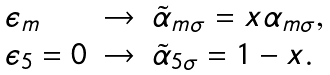Convert formula to latex. <formula><loc_0><loc_0><loc_500><loc_500>\begin{array} { l l l } \epsilon _ { m } & \rightarrow & \tilde { \alpha } _ { m \sigma } = x \alpha _ { m \sigma } , \\ \epsilon _ { 5 } = 0 & \rightarrow & \tilde { \alpha } _ { 5 \sigma } = 1 - x . \end{array}</formula> 